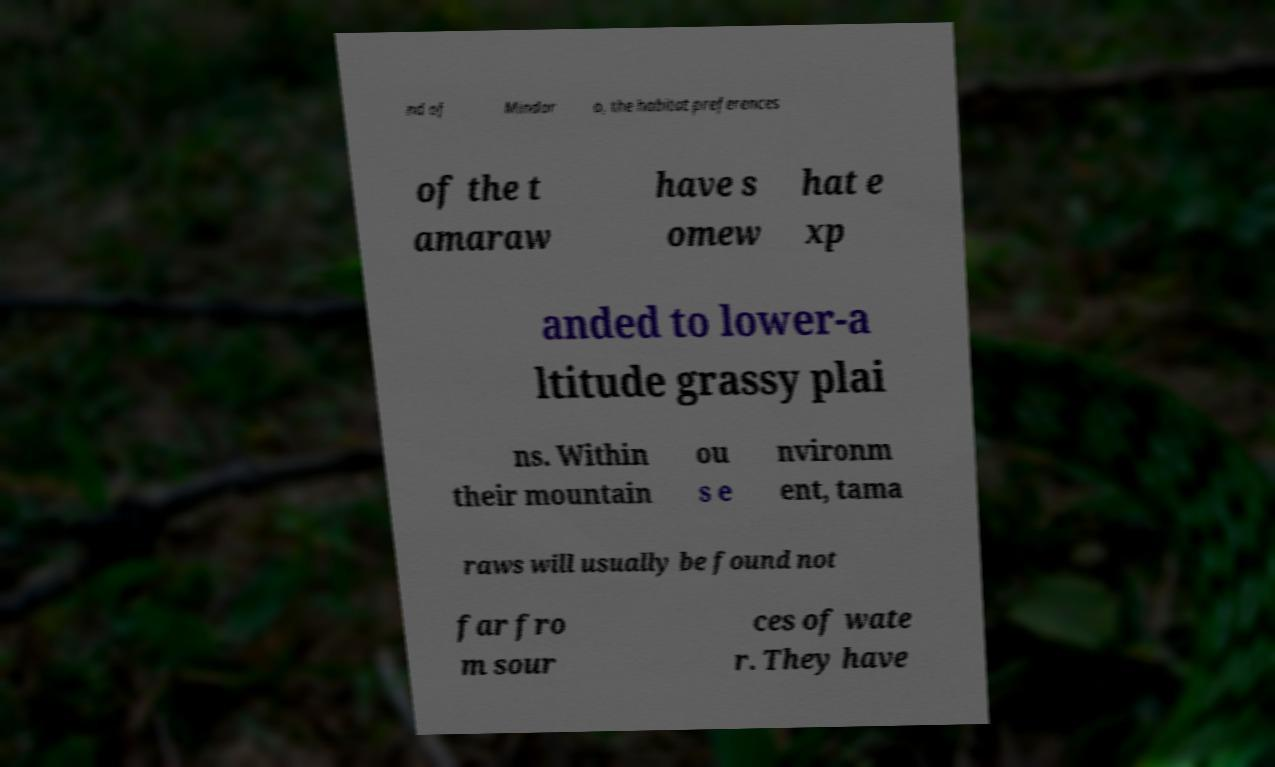Can you read and provide the text displayed in the image?This photo seems to have some interesting text. Can you extract and type it out for me? nd of Mindor o, the habitat preferences of the t amaraw have s omew hat e xp anded to lower-a ltitude grassy plai ns. Within their mountain ou s e nvironm ent, tama raws will usually be found not far fro m sour ces of wate r. They have 